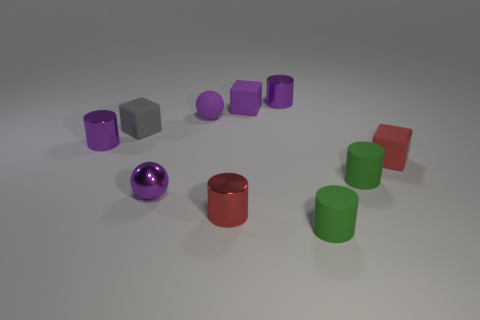Does the tiny shiny ball have the same color as the small rubber ball?
Provide a short and direct response. Yes. Are there more tiny metal objects than purple shiny cylinders?
Offer a very short reply. Yes. The small metal cylinder on the left side of the gray rubber block is what color?
Provide a succinct answer. Purple. What size is the metallic cylinder that is both on the right side of the gray cube and behind the small red metal object?
Give a very brief answer. Small. What number of green cylinders are the same size as the purple shiny ball?
Your response must be concise. 2. There is a tiny red object that is the same shape as the tiny gray thing; what material is it?
Make the answer very short. Rubber. Is the shape of the tiny red matte object the same as the tiny gray matte thing?
Keep it short and to the point. Yes. There is a purple rubber sphere; what number of purple matte objects are behind it?
Offer a very short reply. 1. The small purple shiny thing in front of the small purple metal cylinder on the left side of the small gray rubber object is what shape?
Provide a short and direct response. Sphere. The small red thing that is the same material as the gray object is what shape?
Ensure brevity in your answer.  Cube. 